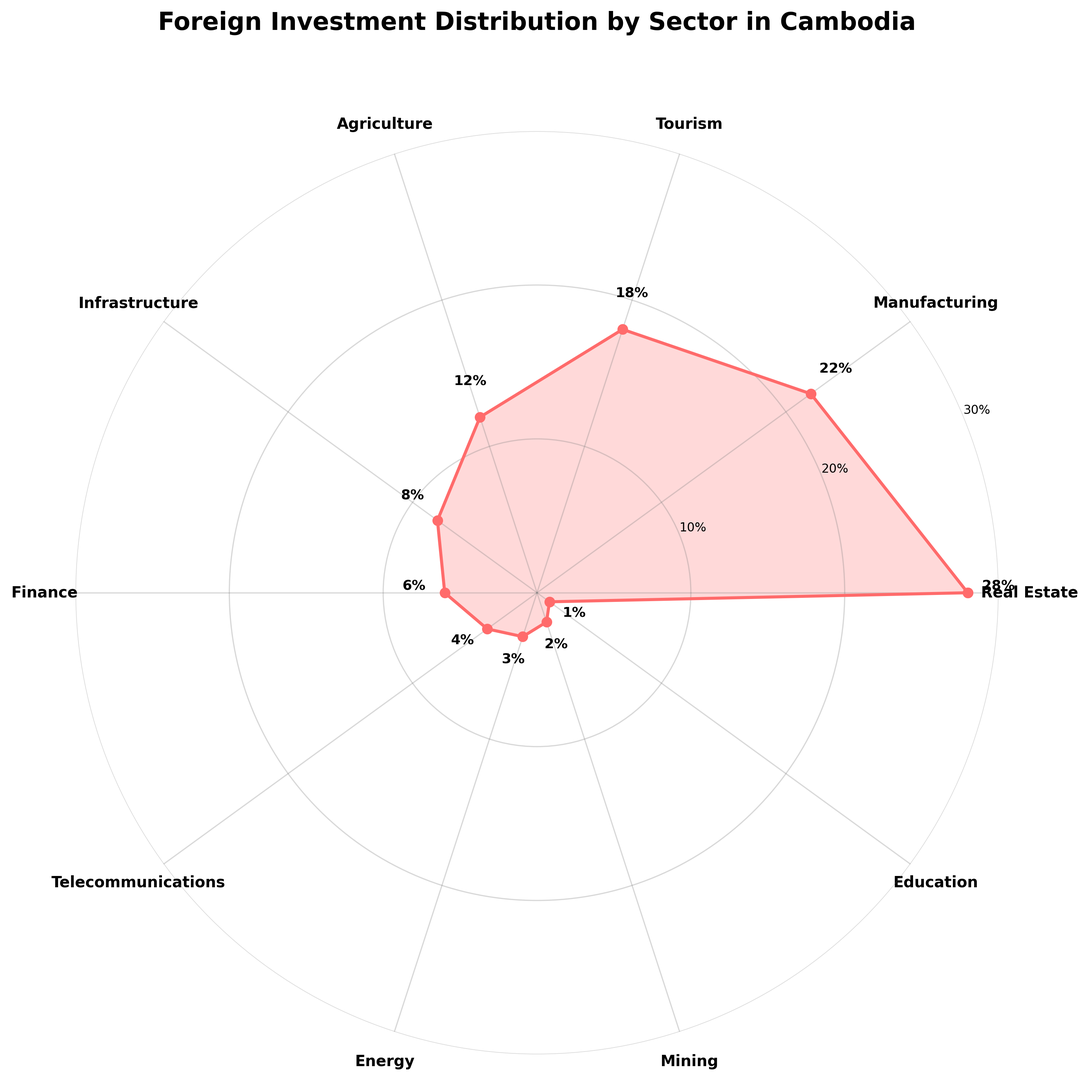Which sector has the highest percentage of foreign investment? The sectors are listed around the radar chart, with Real Estate showing the highest percentage value at 28%.
Answer: Real Estate Which sector has the lowest percentage of foreign investment? The sectors are listed around the radar chart, with Education showing the lowest percentage value at 1%.
Answer: Education How much higher is the percentage of investment in Manufacturing compared to Agriculture? The chart shows that Manufacturing has 22% and Agriculture has 12%. The difference is 22% - 12% = 10%.
Answer: 10% What is the combined percentage of investment in Infrastructure, Finance, and Telecommunications? Add the percentages of the three sectors: Infrastructure (8%) + Finance (6%) + Telecommunications (4%) = 18%.
Answer: 18% Which sector has a percentage of investment closest to 20%? The chart shows that Manufacturing has 22%, which is closest to 20% compared to the other sectors.
Answer: Manufacturing Between Tourism and Agriculture, which sector has a higher percentage of investment? The chart shows that Tourism has 18% and Agriculture has 12%. Tourism has a higher percentage.
Answer: Tourism What is the difference between the highest and second-highest percentages of foreign investment? The highest percentage is Real Estate at 28%, and the second-highest is Manufacturing at 22%. The difference is 28% - 22% = 6%.
Answer: 6% What is the total percentage of investment in sectors with single-digit percentages? Add the percentages of these sectors: Infrastructure (8%) + Finance (6%) + Telecommunications (4%) + Energy (3%) + Mining (2%) + Education (1%) = 24%.
Answer: 24% Which sector has a percentage of investment that is half of Tourism's percentage? Tourism has 18%. Half of 18% is 9%. None of the sectors have exactly 9%, but Infrastructure is the closest with 8%.
Answer: Infrastructure 